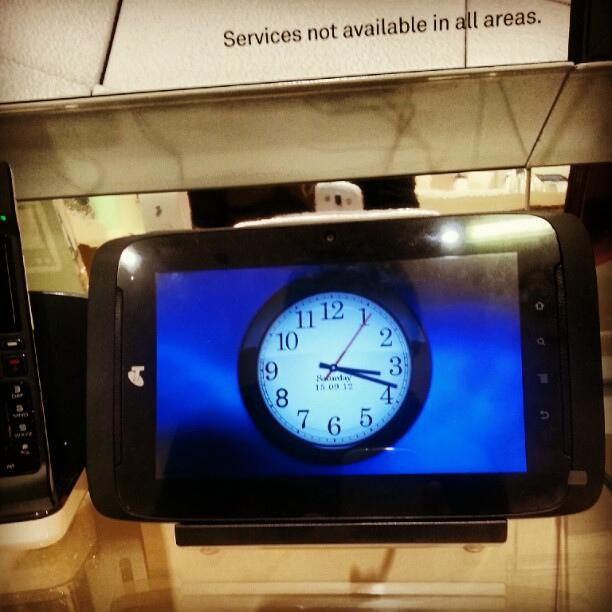What numbered day of the week is it? Please explain your reasoning. seven. The day is the seventh. 